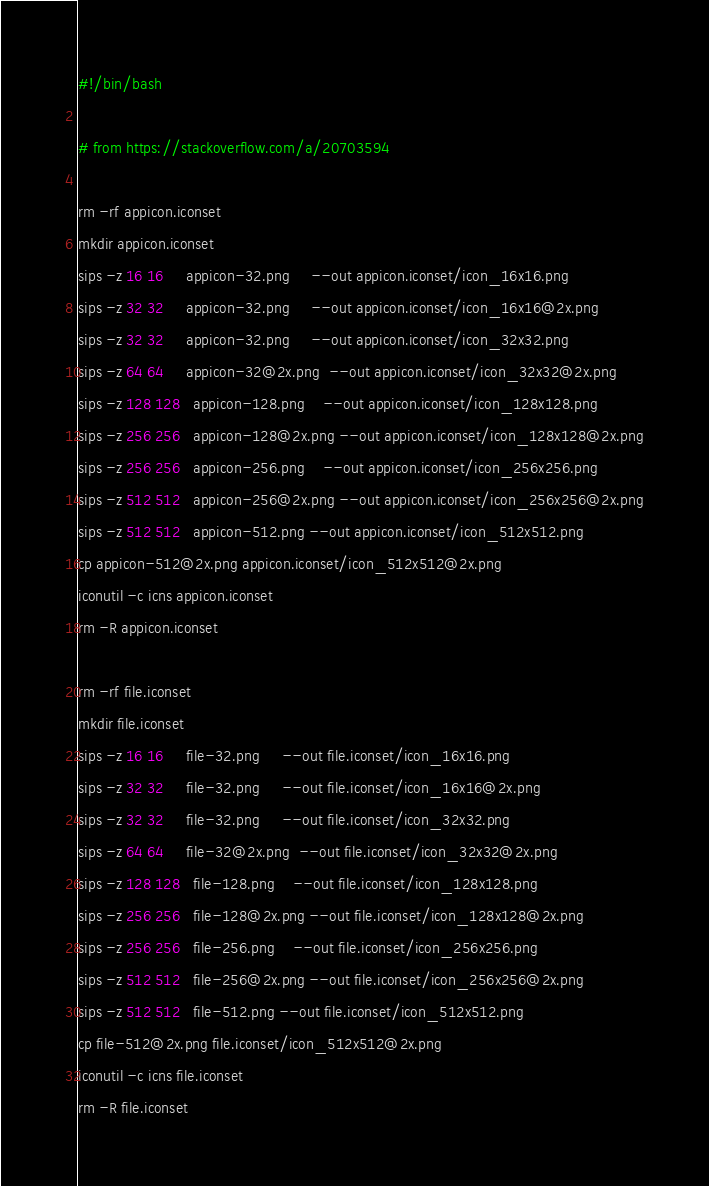Convert code to text. <code><loc_0><loc_0><loc_500><loc_500><_Bash_>#!/bin/bash

# from https://stackoverflow.com/a/20703594

rm -rf appicon.iconset
mkdir appicon.iconset
sips -z 16 16     appicon-32.png     --out appicon.iconset/icon_16x16.png
sips -z 32 32     appicon-32.png     --out appicon.iconset/icon_16x16@2x.png
sips -z 32 32     appicon-32.png     --out appicon.iconset/icon_32x32.png
sips -z 64 64     appicon-32@2x.png  --out appicon.iconset/icon_32x32@2x.png
sips -z 128 128   appicon-128.png    --out appicon.iconset/icon_128x128.png
sips -z 256 256   appicon-128@2x.png --out appicon.iconset/icon_128x128@2x.png
sips -z 256 256   appicon-256.png    --out appicon.iconset/icon_256x256.png
sips -z 512 512   appicon-256@2x.png --out appicon.iconset/icon_256x256@2x.png
sips -z 512 512   appicon-512.png --out appicon.iconset/icon_512x512.png
cp appicon-512@2x.png appicon.iconset/icon_512x512@2x.png
iconutil -c icns appicon.iconset
rm -R appicon.iconset

rm -rf file.iconset
mkdir file.iconset
sips -z 16 16     file-32.png     --out file.iconset/icon_16x16.png
sips -z 32 32     file-32.png     --out file.iconset/icon_16x16@2x.png
sips -z 32 32     file-32.png     --out file.iconset/icon_32x32.png
sips -z 64 64     file-32@2x.png  --out file.iconset/icon_32x32@2x.png
sips -z 128 128   file-128.png    --out file.iconset/icon_128x128.png
sips -z 256 256   file-128@2x.png --out file.iconset/icon_128x128@2x.png
sips -z 256 256   file-256.png    --out file.iconset/icon_256x256.png
sips -z 512 512   file-256@2x.png --out file.iconset/icon_256x256@2x.png
sips -z 512 512   file-512.png --out file.iconset/icon_512x512.png
cp file-512@2x.png file.iconset/icon_512x512@2x.png
iconutil -c icns file.iconset
rm -R file.iconset</code> 